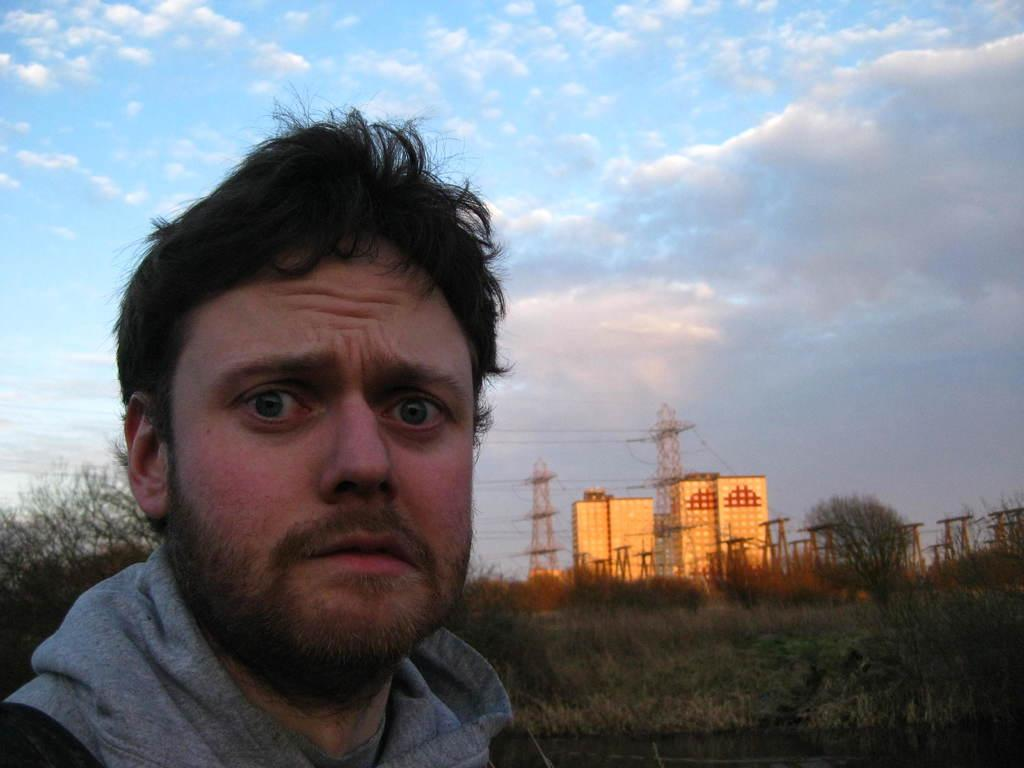Who is present in the image? There is a man in the image. What type of natural environment is visible in the image? There is grass and trees in the image. What type of structures can be seen in the image? There are buildings and towers in the image. What is visible in the background of the image? The sky is visible in the background of the image, with clouds present. What type of advertisement can be seen on the man's shirt in the image? There is no advertisement visible on the man's shirt in the image. 